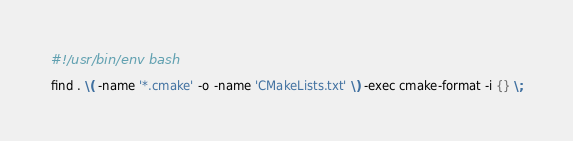<code> <loc_0><loc_0><loc_500><loc_500><_Bash_>#!/usr/bin/env bash

find . \( -name '*.cmake' -o -name 'CMakeLists.txt' \) -exec cmake-format -i {} \;
</code> 